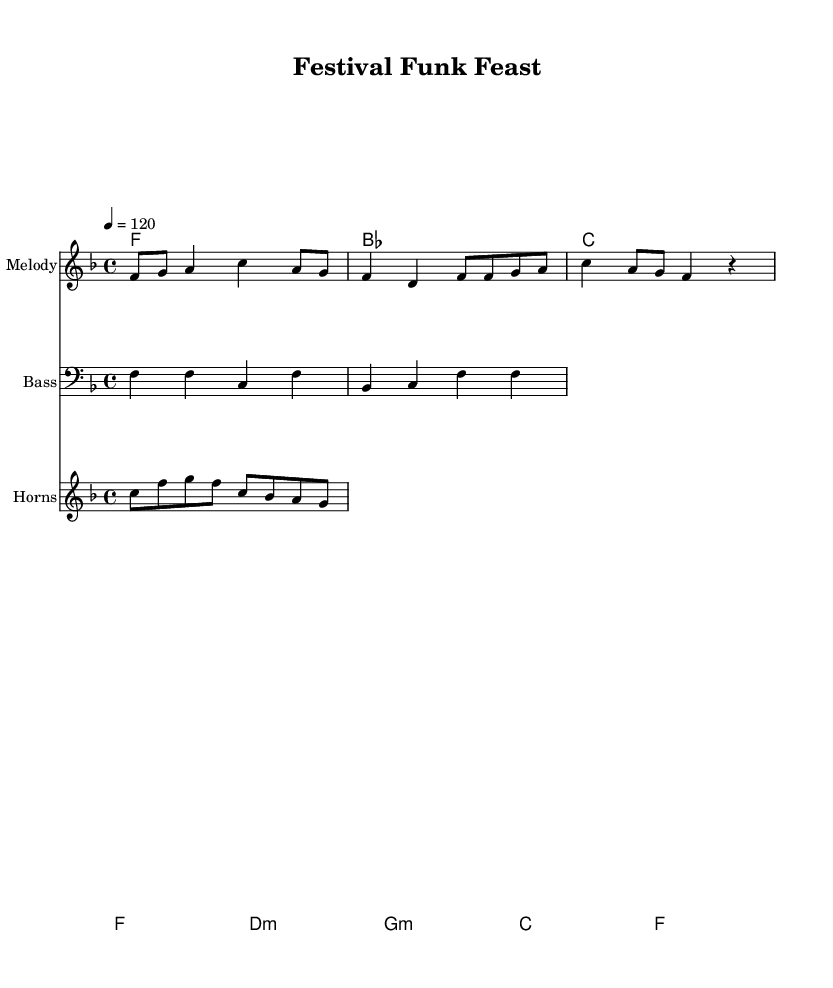What is the key signature of this music? The key signature is F major, which has one flat (B flat). This is determined by looking at the key signature at the beginning of the staff.
Answer: F major What is the time signature of this music? The time signature is 4/4, which means there are four beats in each measure and the quarter note gets one beat. This is indicated at the beginning of the sheet music.
Answer: 4/4 What is the tempo marking in this piece? The tempo marking is 120 beats per minute. This can be found next to the tempo indication at the start of the score, specifying the speed of the performance.
Answer: 120 Which instrument plays the melody? The melody is played by the staff labeled "Melody" in the score. It shows the notes that are in the treble clef, indicating the instrument typically playing the lead.
Answer: Melody How many measures are in the melody section of the music? The melody section consists of 4 measures. This can be counted by looking at the number of bar lines in the melody staff which separate the different measures.
Answer: 4 What type of chords are used in the chord progression? The chords used in the progression include major and minor chords, specifically F, B flat, C, D minor, and G minor. These are identified by reading the chord names below the staff.
Answer: Major and minor What genre and style does this music represent? This music represents Rhythm and Blues with an upbeat funk style, indicated by the lively rhythm and instrumentation associated with vibrant street festivals. This can be inferred from the title and arrangement of the piece.
Answer: Rhythm and Blues 